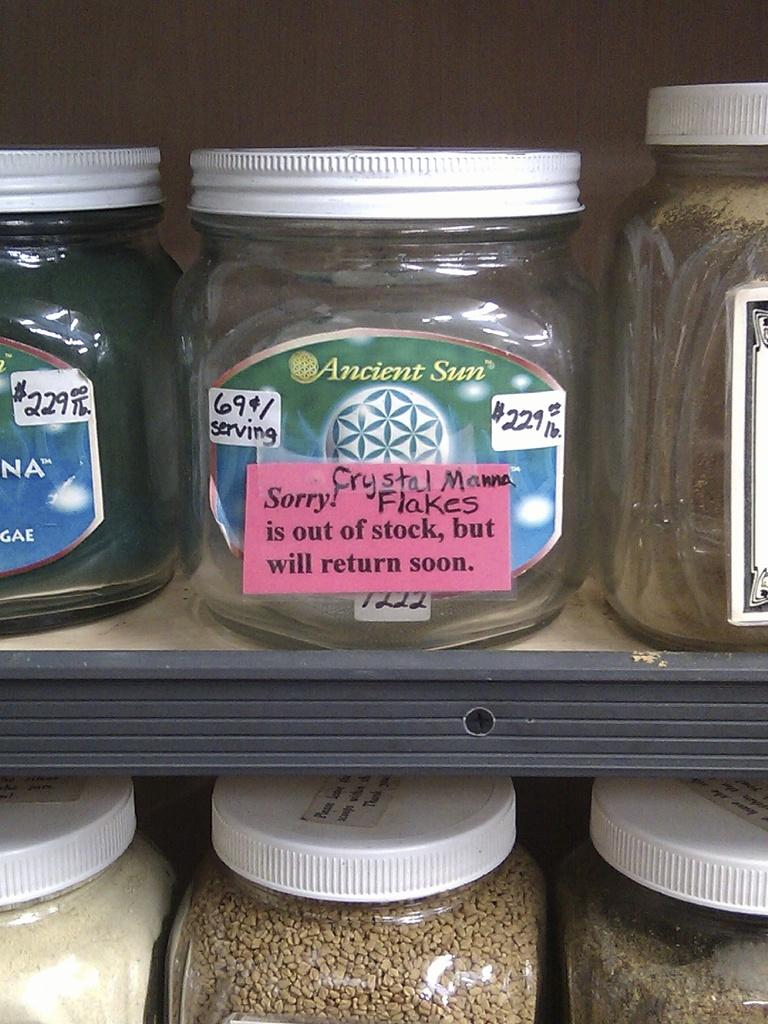Provide a one-sentence caption for the provided image. a jar of Ancient Sun flakes are out of stock. 